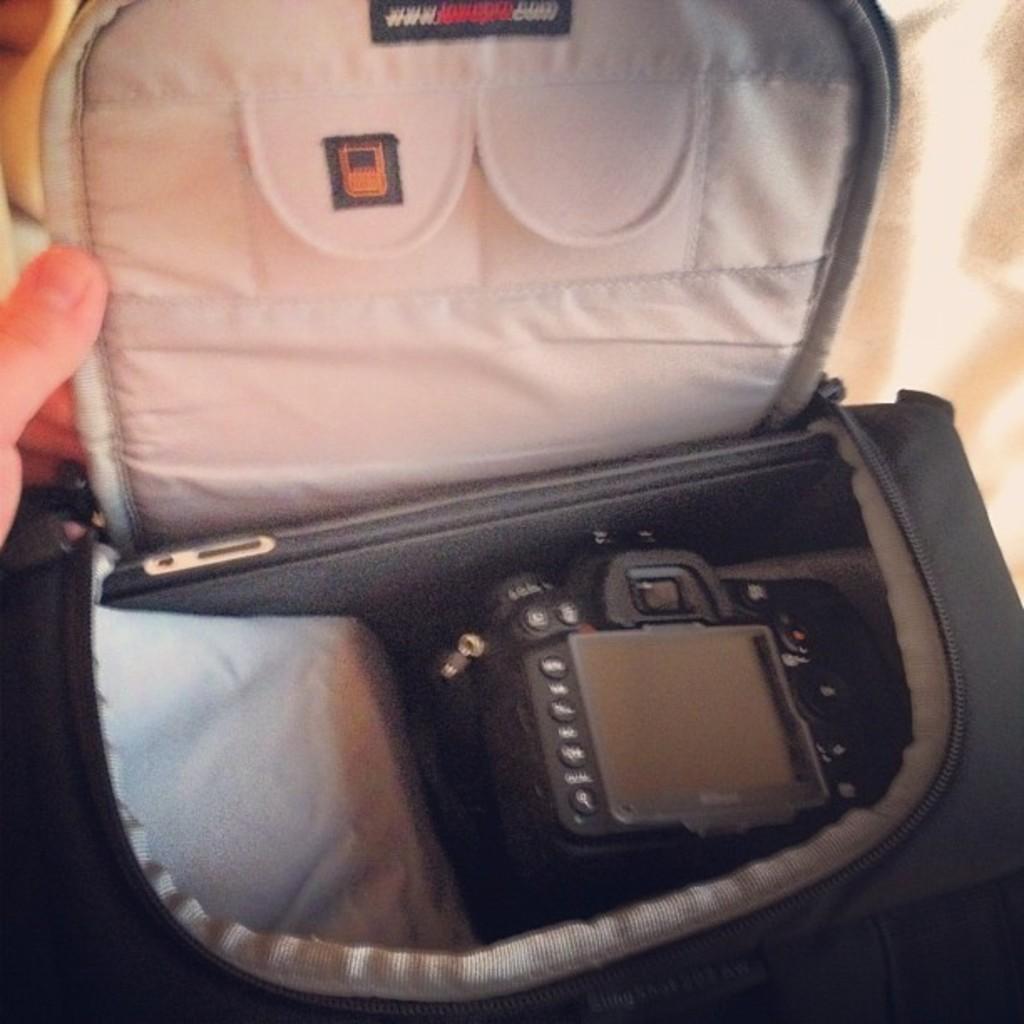Can you describe this image briefly? In this image we can see a black color bag and a camera in it. 